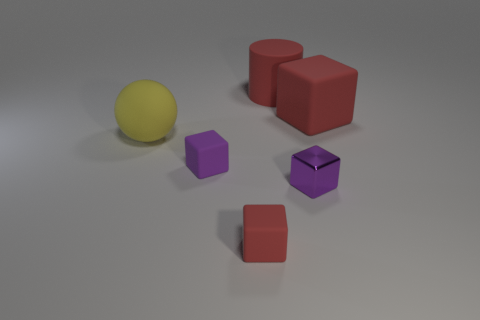How many things are both behind the large yellow matte sphere and to the right of the rubber cylinder?
Your response must be concise. 1. What number of things are small blue metal blocks or large objects to the left of the red cylinder?
Your answer should be very brief. 1. The large object that is the same color as the big block is what shape?
Your response must be concise. Cylinder. The large rubber object that is right of the big cylinder is what color?
Ensure brevity in your answer.  Red. How many objects are yellow balls that are in front of the large rubber cylinder or rubber blocks?
Provide a succinct answer. 4. The matte ball that is the same size as the cylinder is what color?
Offer a very short reply. Yellow. Are there more big yellow things that are to the right of the large cube than large green metal spheres?
Your answer should be compact. No. What is the material of the thing that is both behind the yellow object and in front of the red cylinder?
Your answer should be compact. Rubber. Is the color of the small rubber object behind the tiny red rubber object the same as the large rubber object on the right side of the large cylinder?
Provide a short and direct response. No. There is a thing behind the matte cube that is to the right of the small metallic object; is there a large matte thing in front of it?
Your answer should be very brief. Yes. 